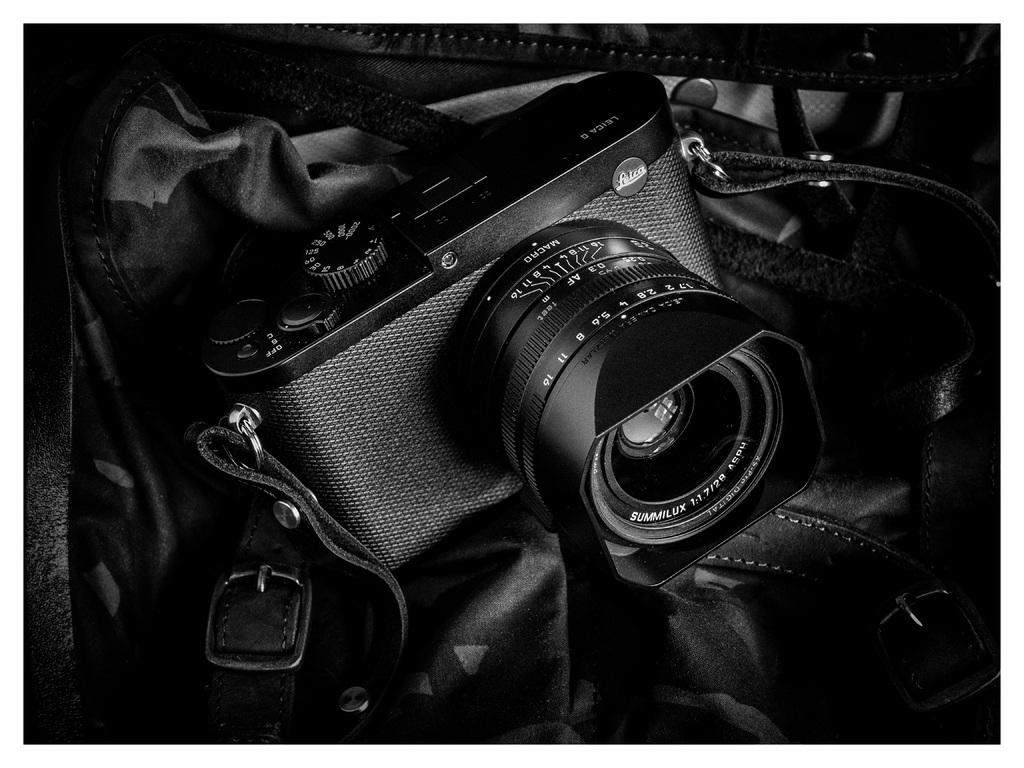What is the color scheme of the image? The image is black and white. What object can be seen in the image? There is a camera in the image. What else is present in the image besides the camera? There is a bag in the image. How does the wine affect the pollution in the image? There is no wine or pollution present in the image; it only features a camera and a bag. 